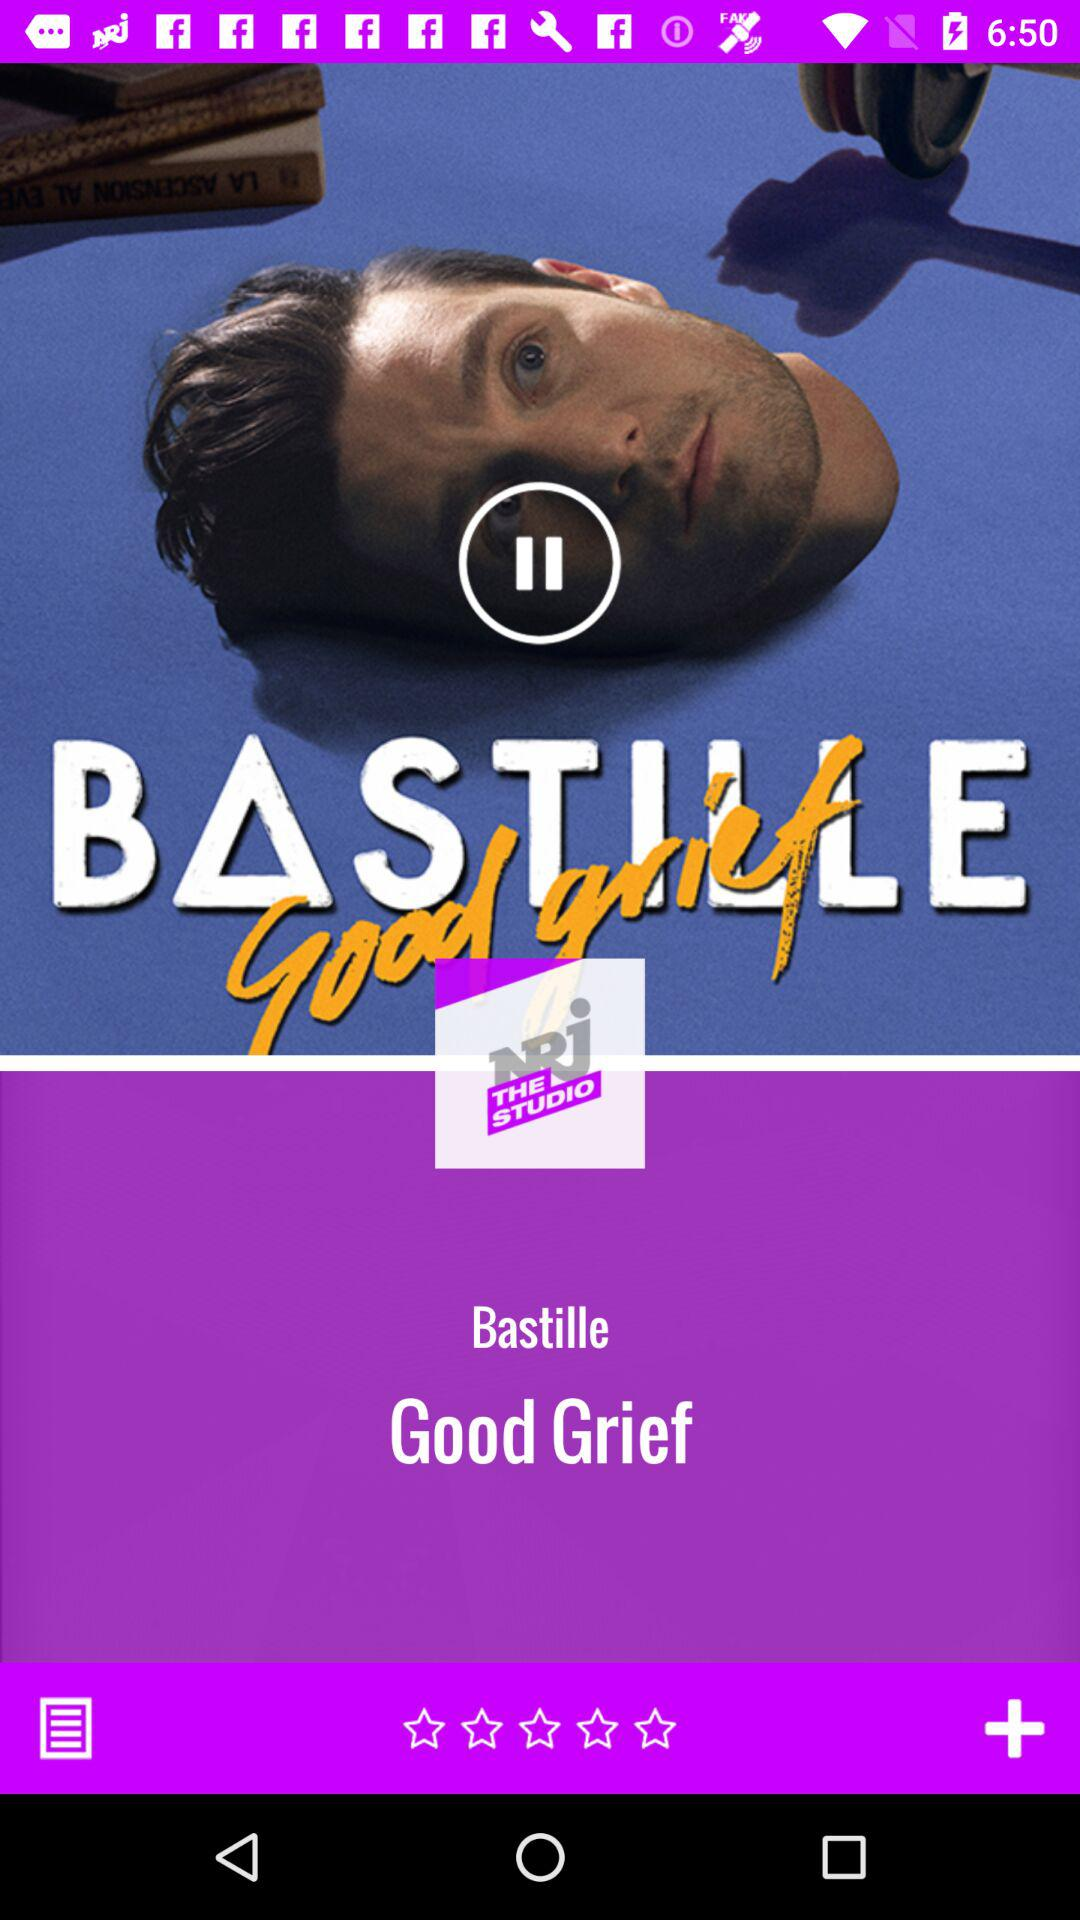What is the app name?
When the provided information is insufficient, respond with <no answer>. <no answer> 